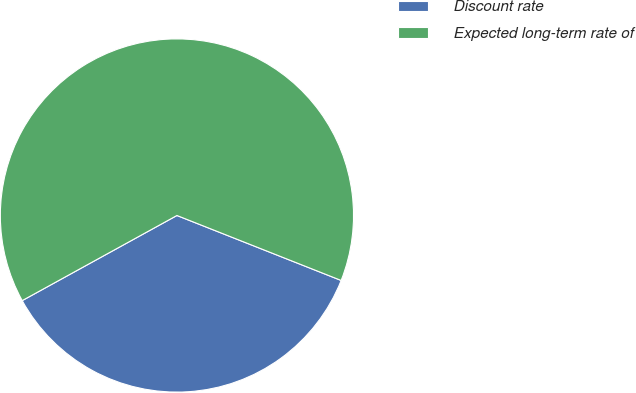Convert chart to OTSL. <chart><loc_0><loc_0><loc_500><loc_500><pie_chart><fcel>Discount rate<fcel>Expected long-term rate of<nl><fcel>36.0%<fcel>64.0%<nl></chart> 